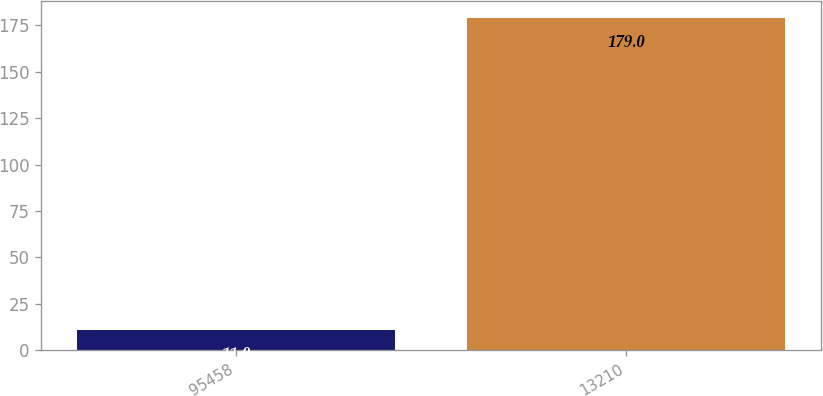Convert chart. <chart><loc_0><loc_0><loc_500><loc_500><bar_chart><fcel>95458<fcel>13210<nl><fcel>11<fcel>179<nl></chart> 